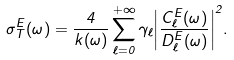Convert formula to latex. <formula><loc_0><loc_0><loc_500><loc_500>\sigma ^ { E } _ { T } ( \omega ) = \frac { 4 } { k ( \omega ) } \sum _ { \ell = 0 } ^ { + \infty } \gamma _ { \ell } { \left | \frac { C ^ { E } _ { \ell } ( \omega ) } { D ^ { E } _ { \ell } ( \omega ) } \right | } ^ { 2 } .</formula> 